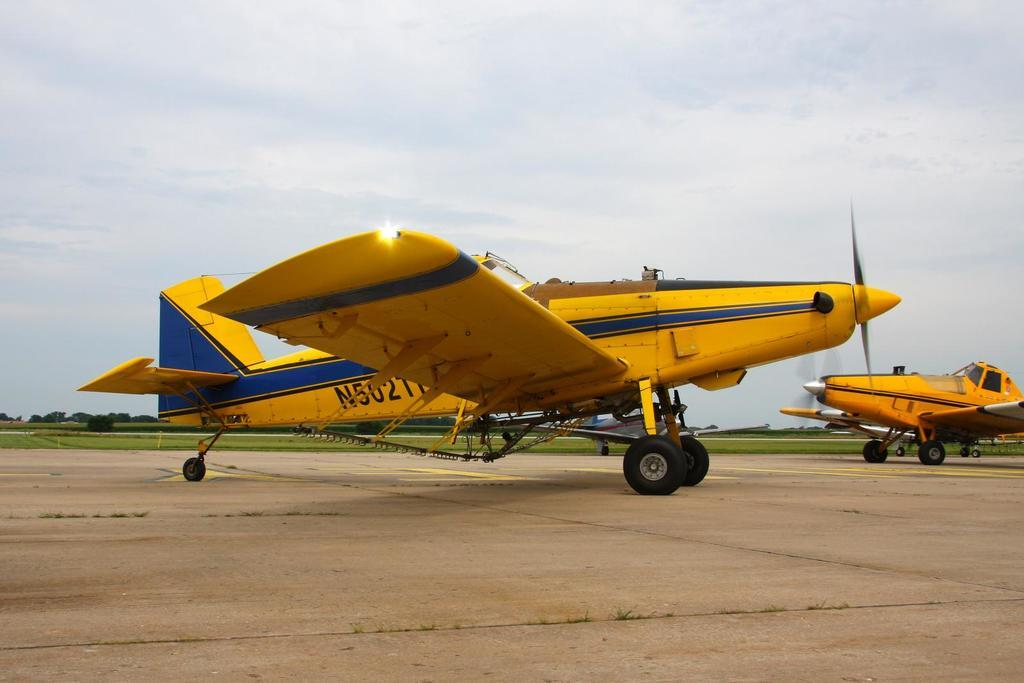<image>
Describe the image concisely. Two yellow single engine airplanes are taxiing on the runway and one has a tail number that says N5021. 